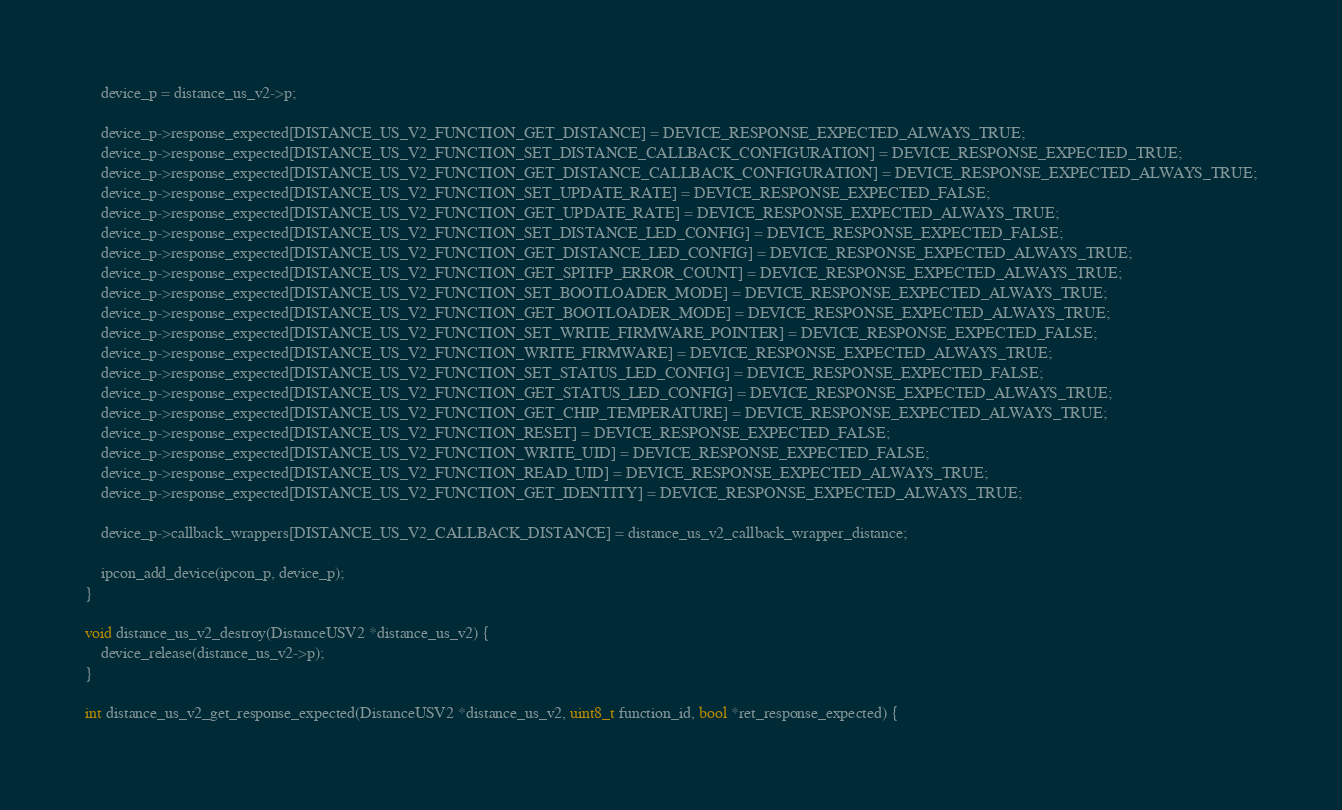<code> <loc_0><loc_0><loc_500><loc_500><_C++_>	device_p = distance_us_v2->p;

	device_p->response_expected[DISTANCE_US_V2_FUNCTION_GET_DISTANCE] = DEVICE_RESPONSE_EXPECTED_ALWAYS_TRUE;
	device_p->response_expected[DISTANCE_US_V2_FUNCTION_SET_DISTANCE_CALLBACK_CONFIGURATION] = DEVICE_RESPONSE_EXPECTED_TRUE;
	device_p->response_expected[DISTANCE_US_V2_FUNCTION_GET_DISTANCE_CALLBACK_CONFIGURATION] = DEVICE_RESPONSE_EXPECTED_ALWAYS_TRUE;
	device_p->response_expected[DISTANCE_US_V2_FUNCTION_SET_UPDATE_RATE] = DEVICE_RESPONSE_EXPECTED_FALSE;
	device_p->response_expected[DISTANCE_US_V2_FUNCTION_GET_UPDATE_RATE] = DEVICE_RESPONSE_EXPECTED_ALWAYS_TRUE;
	device_p->response_expected[DISTANCE_US_V2_FUNCTION_SET_DISTANCE_LED_CONFIG] = DEVICE_RESPONSE_EXPECTED_FALSE;
	device_p->response_expected[DISTANCE_US_V2_FUNCTION_GET_DISTANCE_LED_CONFIG] = DEVICE_RESPONSE_EXPECTED_ALWAYS_TRUE;
	device_p->response_expected[DISTANCE_US_V2_FUNCTION_GET_SPITFP_ERROR_COUNT] = DEVICE_RESPONSE_EXPECTED_ALWAYS_TRUE;
	device_p->response_expected[DISTANCE_US_V2_FUNCTION_SET_BOOTLOADER_MODE] = DEVICE_RESPONSE_EXPECTED_ALWAYS_TRUE;
	device_p->response_expected[DISTANCE_US_V2_FUNCTION_GET_BOOTLOADER_MODE] = DEVICE_RESPONSE_EXPECTED_ALWAYS_TRUE;
	device_p->response_expected[DISTANCE_US_V2_FUNCTION_SET_WRITE_FIRMWARE_POINTER] = DEVICE_RESPONSE_EXPECTED_FALSE;
	device_p->response_expected[DISTANCE_US_V2_FUNCTION_WRITE_FIRMWARE] = DEVICE_RESPONSE_EXPECTED_ALWAYS_TRUE;
	device_p->response_expected[DISTANCE_US_V2_FUNCTION_SET_STATUS_LED_CONFIG] = DEVICE_RESPONSE_EXPECTED_FALSE;
	device_p->response_expected[DISTANCE_US_V2_FUNCTION_GET_STATUS_LED_CONFIG] = DEVICE_RESPONSE_EXPECTED_ALWAYS_TRUE;
	device_p->response_expected[DISTANCE_US_V2_FUNCTION_GET_CHIP_TEMPERATURE] = DEVICE_RESPONSE_EXPECTED_ALWAYS_TRUE;
	device_p->response_expected[DISTANCE_US_V2_FUNCTION_RESET] = DEVICE_RESPONSE_EXPECTED_FALSE;
	device_p->response_expected[DISTANCE_US_V2_FUNCTION_WRITE_UID] = DEVICE_RESPONSE_EXPECTED_FALSE;
	device_p->response_expected[DISTANCE_US_V2_FUNCTION_READ_UID] = DEVICE_RESPONSE_EXPECTED_ALWAYS_TRUE;
	device_p->response_expected[DISTANCE_US_V2_FUNCTION_GET_IDENTITY] = DEVICE_RESPONSE_EXPECTED_ALWAYS_TRUE;

	device_p->callback_wrappers[DISTANCE_US_V2_CALLBACK_DISTANCE] = distance_us_v2_callback_wrapper_distance;

	ipcon_add_device(ipcon_p, device_p);
}

void distance_us_v2_destroy(DistanceUSV2 *distance_us_v2) {
	device_release(distance_us_v2->p);
}

int distance_us_v2_get_response_expected(DistanceUSV2 *distance_us_v2, uint8_t function_id, bool *ret_response_expected) {</code> 